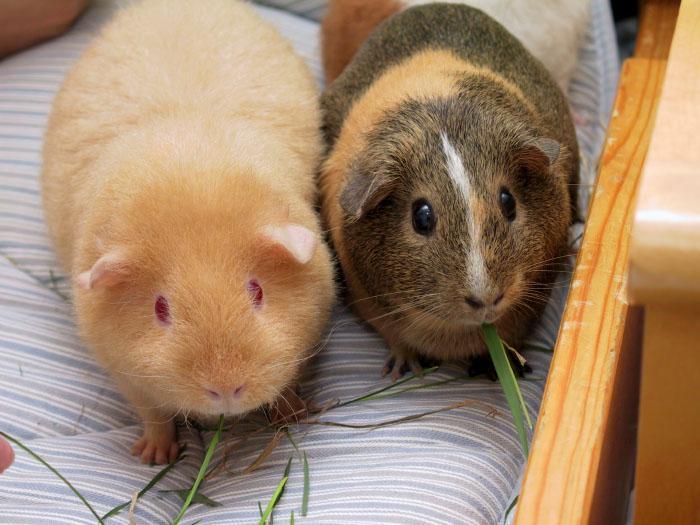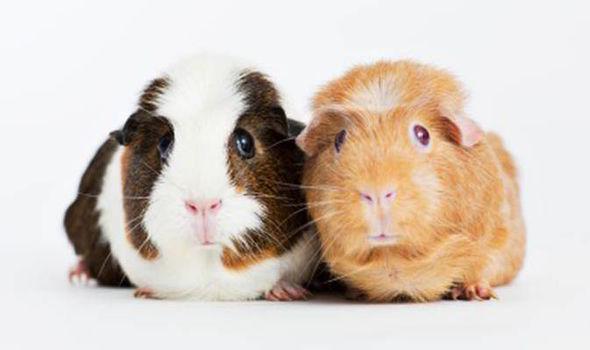The first image is the image on the left, the second image is the image on the right. Analyze the images presented: Is the assertion "There are three hamsters." valid? Answer yes or no. No. The first image is the image on the left, the second image is the image on the right. Considering the images on both sides, is "there are exactly two animals in the image on the left" valid? Answer yes or no. Yes. 